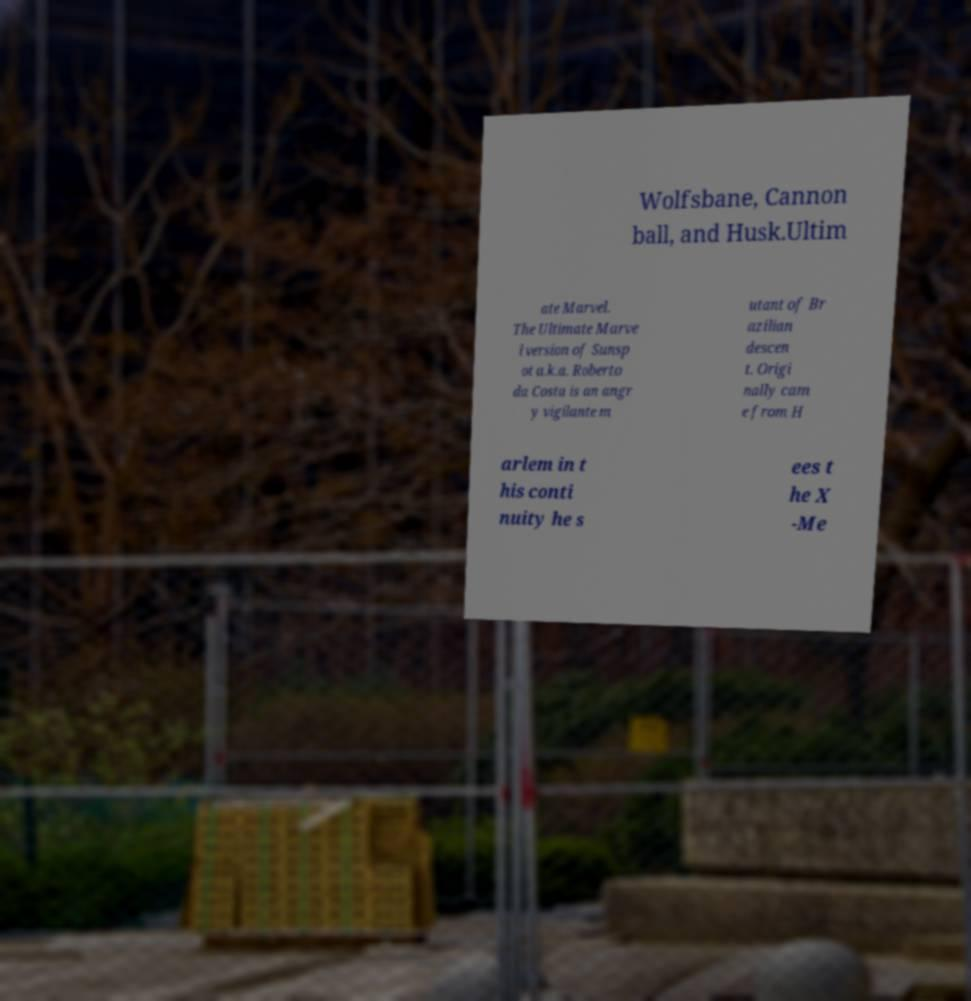Can you accurately transcribe the text from the provided image for me? Wolfsbane, Cannon ball, and Husk.Ultim ate Marvel. The Ultimate Marve l version of Sunsp ot a.k.a. Roberto da Costa is an angr y vigilante m utant of Br azilian descen t. Origi nally cam e from H arlem in t his conti nuity he s ees t he X -Me 